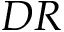<formula> <loc_0><loc_0><loc_500><loc_500>D R</formula> 